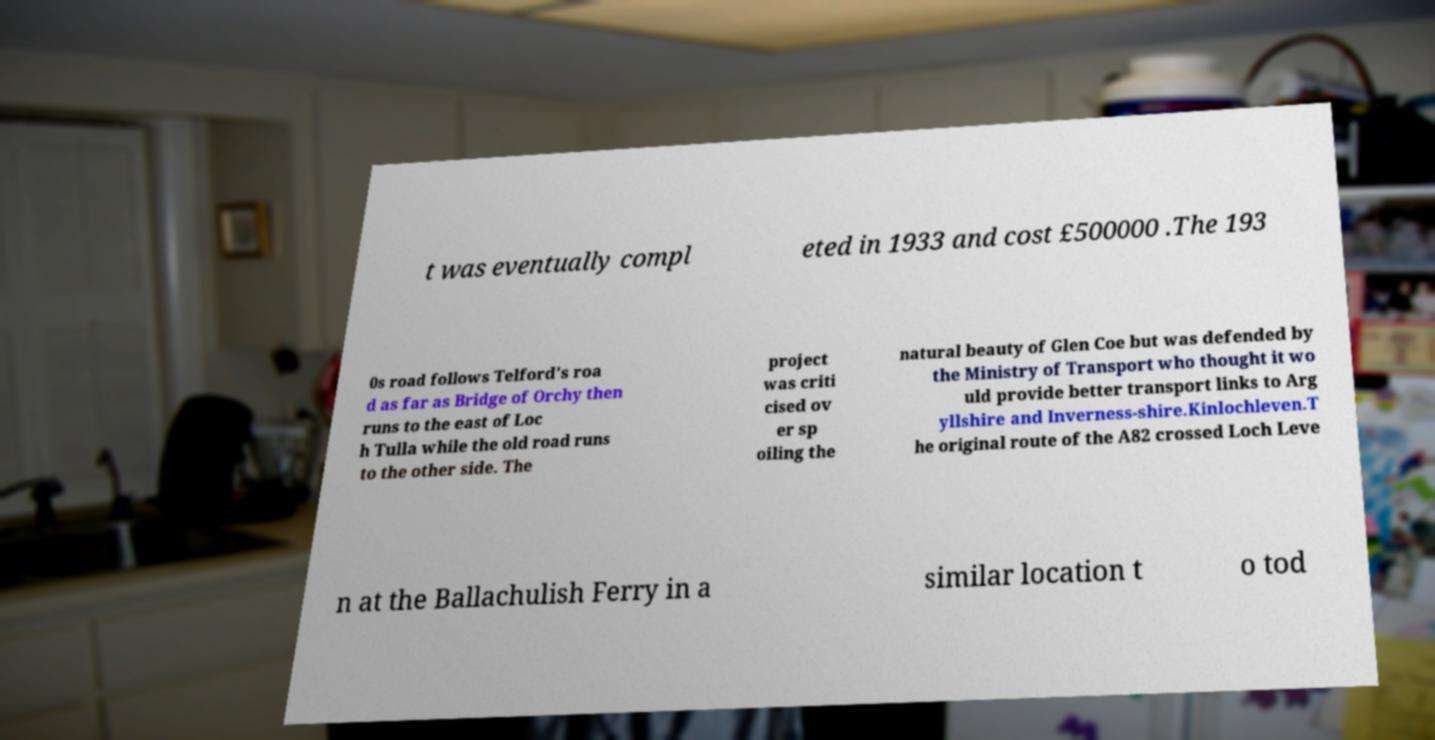Can you read and provide the text displayed in the image?This photo seems to have some interesting text. Can you extract and type it out for me? t was eventually compl eted in 1933 and cost £500000 .The 193 0s road follows Telford's roa d as far as Bridge of Orchy then runs to the east of Loc h Tulla while the old road runs to the other side. The project was criti cised ov er sp oiling the natural beauty of Glen Coe but was defended by the Ministry of Transport who thought it wo uld provide better transport links to Arg yllshire and Inverness-shire.Kinlochleven.T he original route of the A82 crossed Loch Leve n at the Ballachulish Ferry in a similar location t o tod 